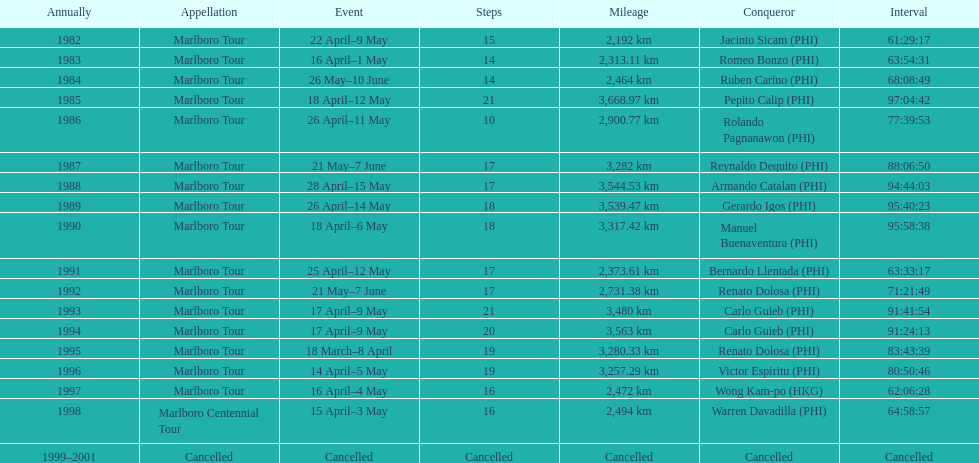Who is listed below romeo bonzo? Ruben Carino (PHI). 